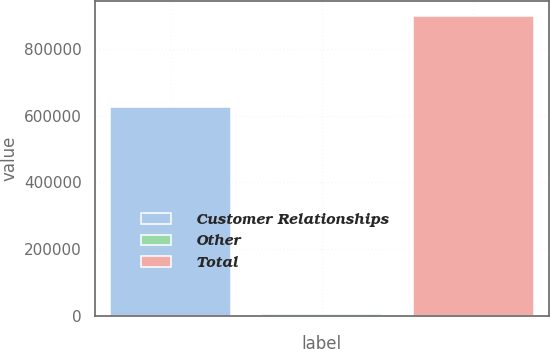Convert chart to OTSL. <chart><loc_0><loc_0><loc_500><loc_500><bar_chart><fcel>Customer Relationships<fcel>Other<fcel>Total<nl><fcel>625263<fcel>6825<fcel>899057<nl></chart> 